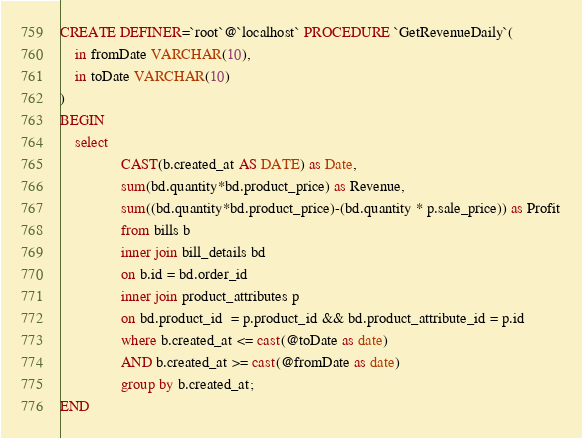Convert code to text. <code><loc_0><loc_0><loc_500><loc_500><_SQL_>CREATE DEFINER=`root`@`localhost` PROCEDURE `GetRevenueDaily`(
	in fromDate VARCHAR(10),
	in toDate VARCHAR(10)
)
BEGIN
	select
                CAST(b.created_at AS DATE) as Date,
                sum(bd.quantity*bd.product_price) as Revenue,
                sum((bd.quantity*bd.product_price)-(bd.quantity * p.sale_price)) as Profit
                from bills b
                inner join bill_details bd
                on b.id = bd.order_id
                inner join product_attributes p
                on bd.product_id  = p.product_id && bd.product_attribute_id = p.id
                where b.created_at <= cast(@toDate as date) 
				AND b.created_at >= cast(@fromDate as date)
                group by b.created_at;
END</code> 